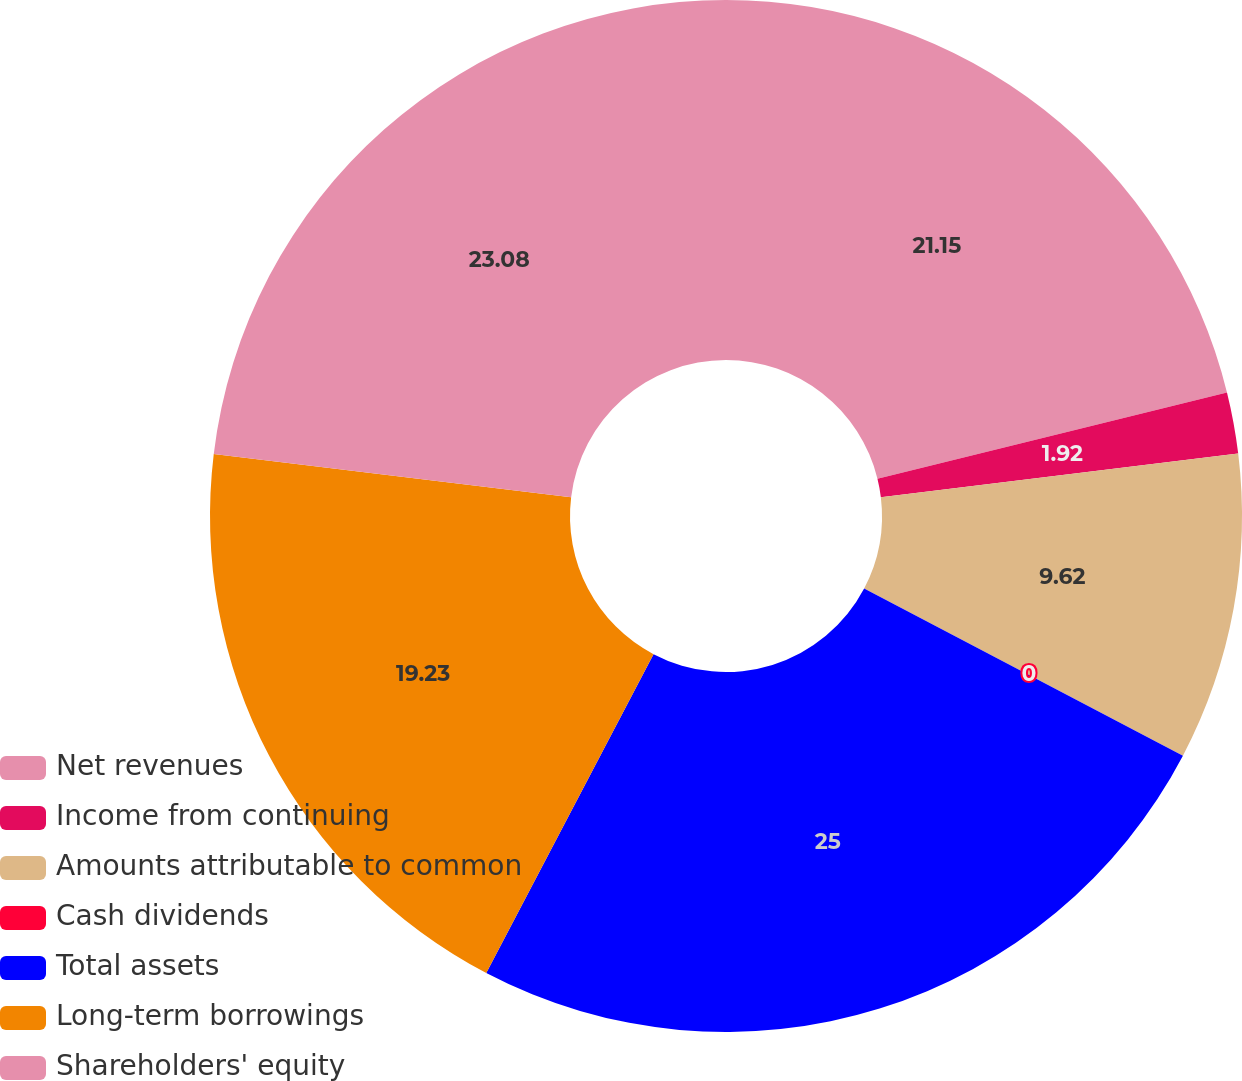<chart> <loc_0><loc_0><loc_500><loc_500><pie_chart><fcel>Net revenues<fcel>Income from continuing<fcel>Amounts attributable to common<fcel>Cash dividends<fcel>Total assets<fcel>Long-term borrowings<fcel>Shareholders' equity<nl><fcel>21.15%<fcel>1.92%<fcel>9.62%<fcel>0.0%<fcel>25.0%<fcel>19.23%<fcel>23.08%<nl></chart> 